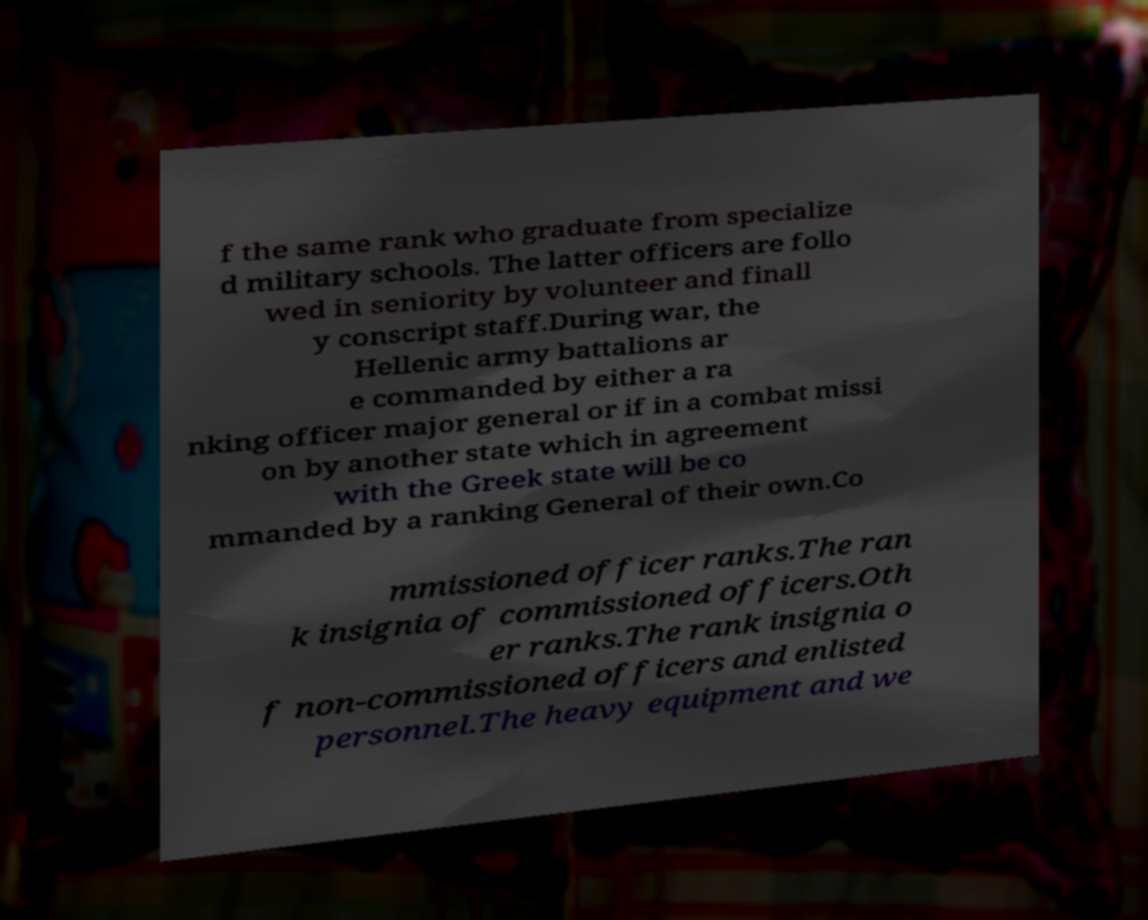Could you extract and type out the text from this image? f the same rank who graduate from specialize d military schools. The latter officers are follo wed in seniority by volunteer and finall y conscript staff.During war, the Hellenic army battalions ar e commanded by either a ra nking officer major general or if in a combat missi on by another state which in agreement with the Greek state will be co mmanded by a ranking General of their own.Co mmissioned officer ranks.The ran k insignia of commissioned officers.Oth er ranks.The rank insignia o f non-commissioned officers and enlisted personnel.The heavy equipment and we 